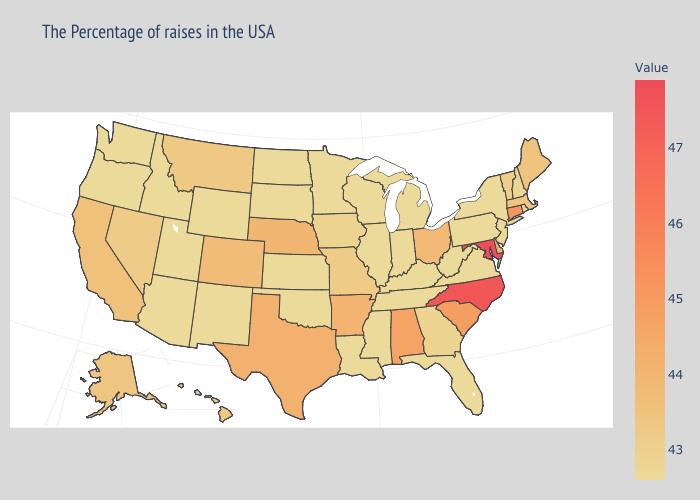Does Missouri have a lower value than Oregon?
Write a very short answer. No. Among the states that border Tennessee , does Georgia have the lowest value?
Concise answer only. No. Does Montana have the lowest value in the USA?
Give a very brief answer. No. 